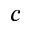<formula> <loc_0><loc_0><loc_500><loc_500>c</formula> 